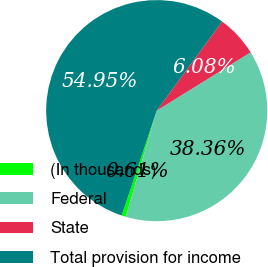<chart> <loc_0><loc_0><loc_500><loc_500><pie_chart><fcel>(In thousands)<fcel>Federal<fcel>State<fcel>Total provision for income<nl><fcel>0.61%<fcel>38.36%<fcel>6.08%<fcel>54.96%<nl></chart> 